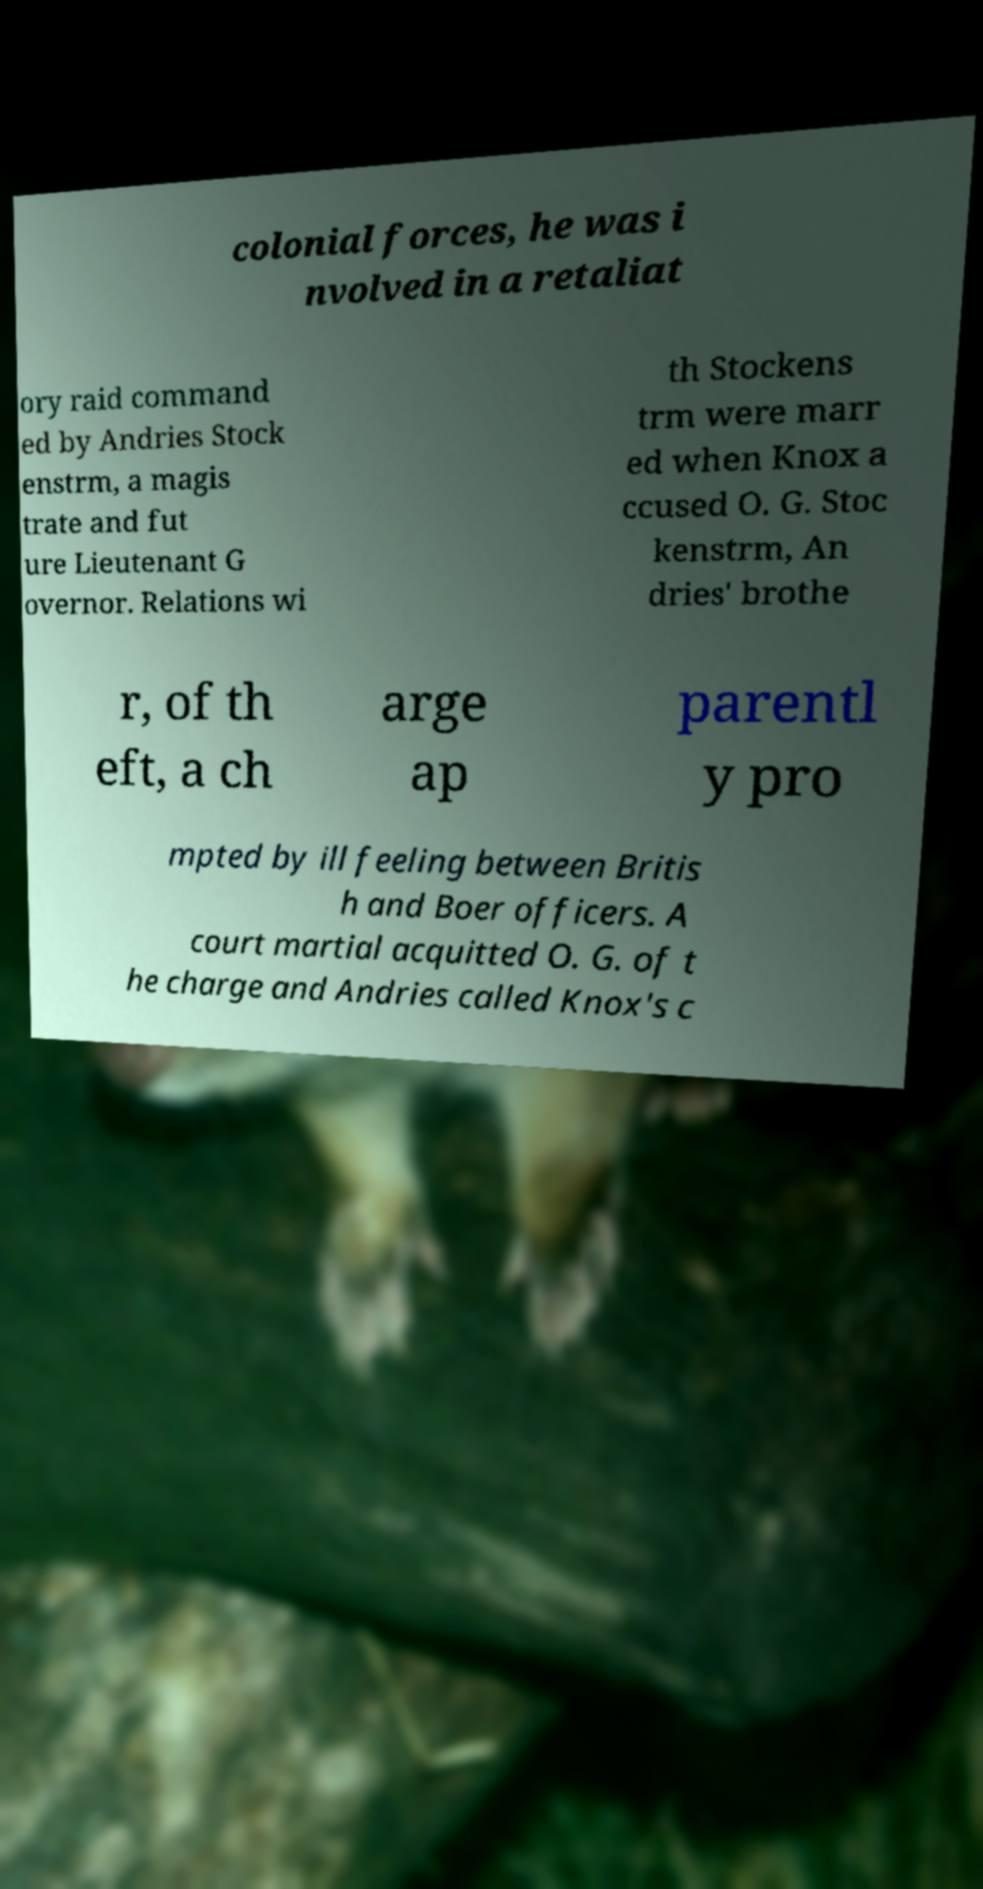I need the written content from this picture converted into text. Can you do that? colonial forces, he was i nvolved in a retaliat ory raid command ed by Andries Stock enstrm, a magis trate and fut ure Lieutenant G overnor. Relations wi th Stockens trm were marr ed when Knox a ccused O. G. Stoc kenstrm, An dries' brothe r, of th eft, a ch arge ap parentl y pro mpted by ill feeling between Britis h and Boer officers. A court martial acquitted O. G. of t he charge and Andries called Knox's c 